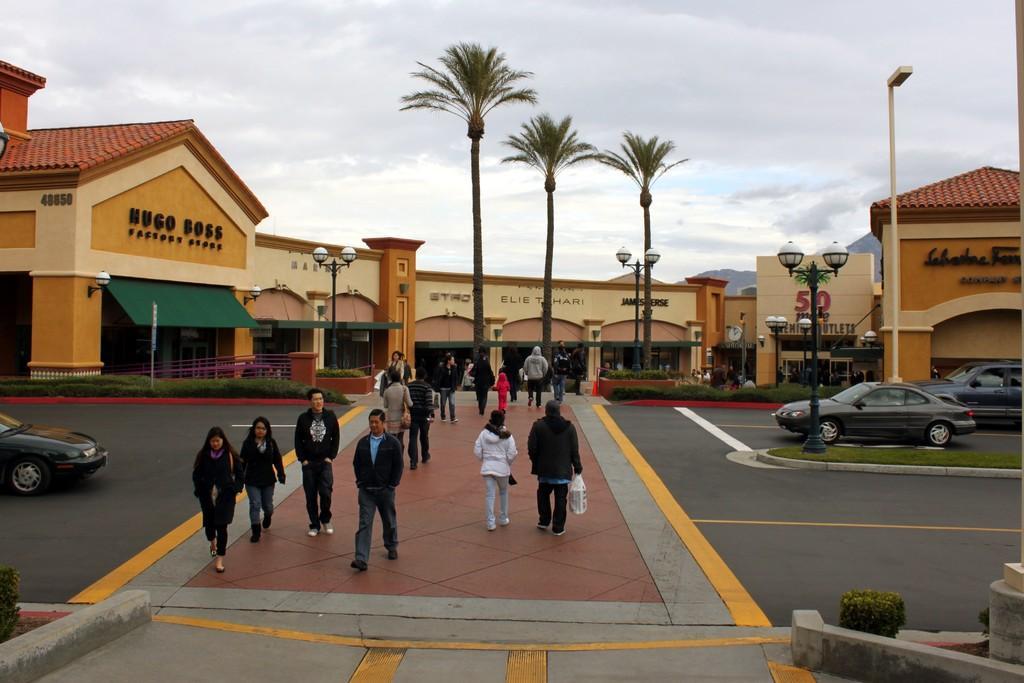Please provide a concise description of this image. In this image, we can see people walking on the side and are wearing coats. In the background, there are vehicles on the road and we can see lights, trees, buildings, poles, a fence and bushes. At the top, there are clouds in the sky. 